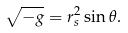<formula> <loc_0><loc_0><loc_500><loc_500>\sqrt { - g } = r _ { s } ^ { 2 } \sin \theta .</formula> 